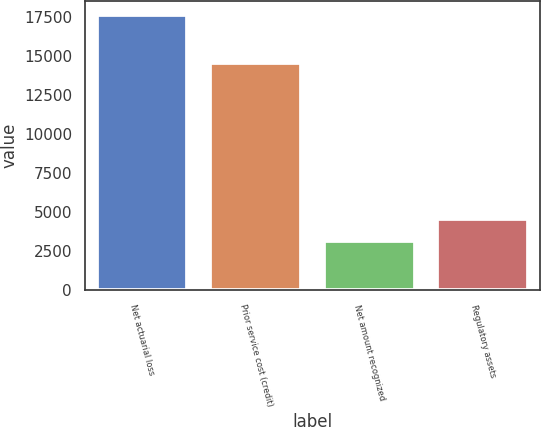<chart> <loc_0><loc_0><loc_500><loc_500><bar_chart><fcel>Net actuarial loss<fcel>Prior service cost (credit)<fcel>Net amount recognized<fcel>Regulatory assets<nl><fcel>17632<fcel>14519<fcel>3113<fcel>4564.9<nl></chart> 